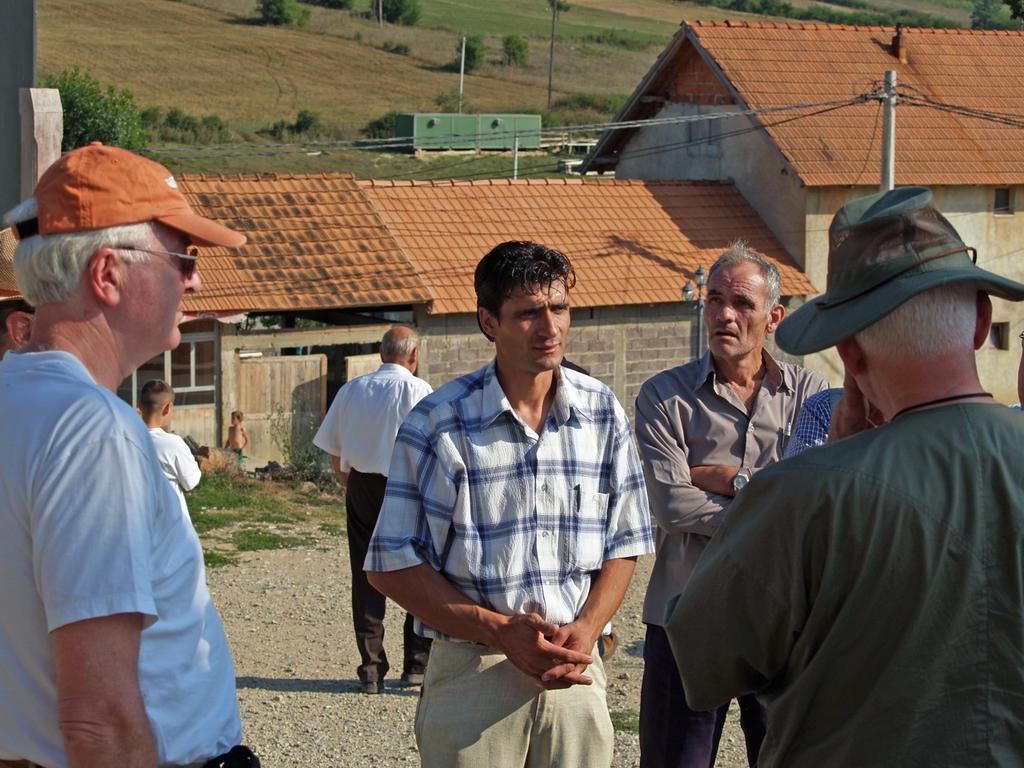How would you summarize this image in a sentence or two? In the image there are few men standing in the foreground and behind them there is some building and in the background there are trees, plants and empty land. 